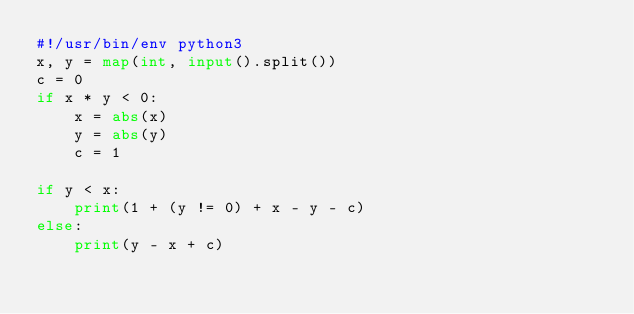Convert code to text. <code><loc_0><loc_0><loc_500><loc_500><_Python_>#!/usr/bin/env python3
x, y = map(int, input().split())
c = 0
if x * y < 0:
    x = abs(x)
    y = abs(y)
    c = 1

if y < x:
    print(1 + (y != 0) + x - y - c)
else:
    print(y - x + c)
</code> 